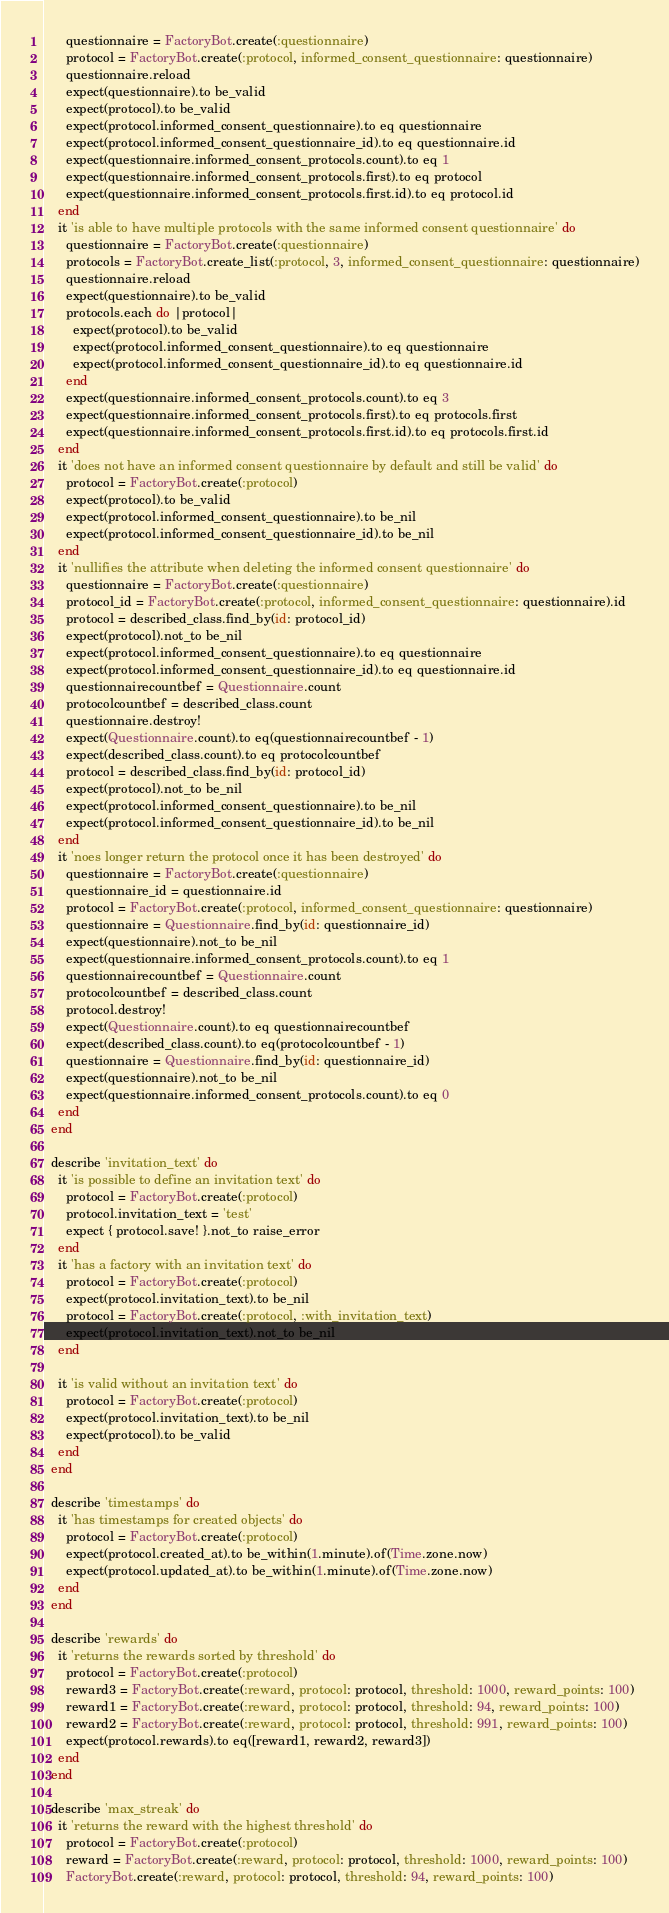<code> <loc_0><loc_0><loc_500><loc_500><_Ruby_>      questionnaire = FactoryBot.create(:questionnaire)
      protocol = FactoryBot.create(:protocol, informed_consent_questionnaire: questionnaire)
      questionnaire.reload
      expect(questionnaire).to be_valid
      expect(protocol).to be_valid
      expect(protocol.informed_consent_questionnaire).to eq questionnaire
      expect(protocol.informed_consent_questionnaire_id).to eq questionnaire.id
      expect(questionnaire.informed_consent_protocols.count).to eq 1
      expect(questionnaire.informed_consent_protocols.first).to eq protocol
      expect(questionnaire.informed_consent_protocols.first.id).to eq protocol.id
    end
    it 'is able to have multiple protocols with the same informed consent questionnaire' do
      questionnaire = FactoryBot.create(:questionnaire)
      protocols = FactoryBot.create_list(:protocol, 3, informed_consent_questionnaire: questionnaire)
      questionnaire.reload
      expect(questionnaire).to be_valid
      protocols.each do |protocol|
        expect(protocol).to be_valid
        expect(protocol.informed_consent_questionnaire).to eq questionnaire
        expect(protocol.informed_consent_questionnaire_id).to eq questionnaire.id
      end
      expect(questionnaire.informed_consent_protocols.count).to eq 3
      expect(questionnaire.informed_consent_protocols.first).to eq protocols.first
      expect(questionnaire.informed_consent_protocols.first.id).to eq protocols.first.id
    end
    it 'does not have an informed consent questionnaire by default and still be valid' do
      protocol = FactoryBot.create(:protocol)
      expect(protocol).to be_valid
      expect(protocol.informed_consent_questionnaire).to be_nil
      expect(protocol.informed_consent_questionnaire_id).to be_nil
    end
    it 'nullifies the attribute when deleting the informed consent questionnaire' do
      questionnaire = FactoryBot.create(:questionnaire)
      protocol_id = FactoryBot.create(:protocol, informed_consent_questionnaire: questionnaire).id
      protocol = described_class.find_by(id: protocol_id)
      expect(protocol).not_to be_nil
      expect(protocol.informed_consent_questionnaire).to eq questionnaire
      expect(protocol.informed_consent_questionnaire_id).to eq questionnaire.id
      questionnairecountbef = Questionnaire.count
      protocolcountbef = described_class.count
      questionnaire.destroy!
      expect(Questionnaire.count).to eq(questionnairecountbef - 1)
      expect(described_class.count).to eq protocolcountbef
      protocol = described_class.find_by(id: protocol_id)
      expect(protocol).not_to be_nil
      expect(protocol.informed_consent_questionnaire).to be_nil
      expect(protocol.informed_consent_questionnaire_id).to be_nil
    end
    it 'noes longer return the protocol once it has been destroyed' do
      questionnaire = FactoryBot.create(:questionnaire)
      questionnaire_id = questionnaire.id
      protocol = FactoryBot.create(:protocol, informed_consent_questionnaire: questionnaire)
      questionnaire = Questionnaire.find_by(id: questionnaire_id)
      expect(questionnaire).not_to be_nil
      expect(questionnaire.informed_consent_protocols.count).to eq 1
      questionnairecountbef = Questionnaire.count
      protocolcountbef = described_class.count
      protocol.destroy!
      expect(Questionnaire.count).to eq questionnairecountbef
      expect(described_class.count).to eq(protocolcountbef - 1)
      questionnaire = Questionnaire.find_by(id: questionnaire_id)
      expect(questionnaire).not_to be_nil
      expect(questionnaire.informed_consent_protocols.count).to eq 0
    end
  end

  describe 'invitation_text' do
    it 'is possible to define an invitation text' do
      protocol = FactoryBot.create(:protocol)
      protocol.invitation_text = 'test'
      expect { protocol.save! }.not_to raise_error
    end
    it 'has a factory with an invitation text' do
      protocol = FactoryBot.create(:protocol)
      expect(protocol.invitation_text).to be_nil
      protocol = FactoryBot.create(:protocol, :with_invitation_text)
      expect(protocol.invitation_text).not_to be_nil
    end

    it 'is valid without an invitation text' do
      protocol = FactoryBot.create(:protocol)
      expect(protocol.invitation_text).to be_nil
      expect(protocol).to be_valid
    end
  end

  describe 'timestamps' do
    it 'has timestamps for created objects' do
      protocol = FactoryBot.create(:protocol)
      expect(protocol.created_at).to be_within(1.minute).of(Time.zone.now)
      expect(protocol.updated_at).to be_within(1.minute).of(Time.zone.now)
    end
  end

  describe 'rewards' do
    it 'returns the rewards sorted by threshold' do
      protocol = FactoryBot.create(:protocol)
      reward3 = FactoryBot.create(:reward, protocol: protocol, threshold: 1000, reward_points: 100)
      reward1 = FactoryBot.create(:reward, protocol: protocol, threshold: 94, reward_points: 100)
      reward2 = FactoryBot.create(:reward, protocol: protocol, threshold: 991, reward_points: 100)
      expect(protocol.rewards).to eq([reward1, reward2, reward3])
    end
  end

  describe 'max_streak' do
    it 'returns the reward with the highest threshold' do
      protocol = FactoryBot.create(:protocol)
      reward = FactoryBot.create(:reward, protocol: protocol, threshold: 1000, reward_points: 100)
      FactoryBot.create(:reward, protocol: protocol, threshold: 94, reward_points: 100)</code> 